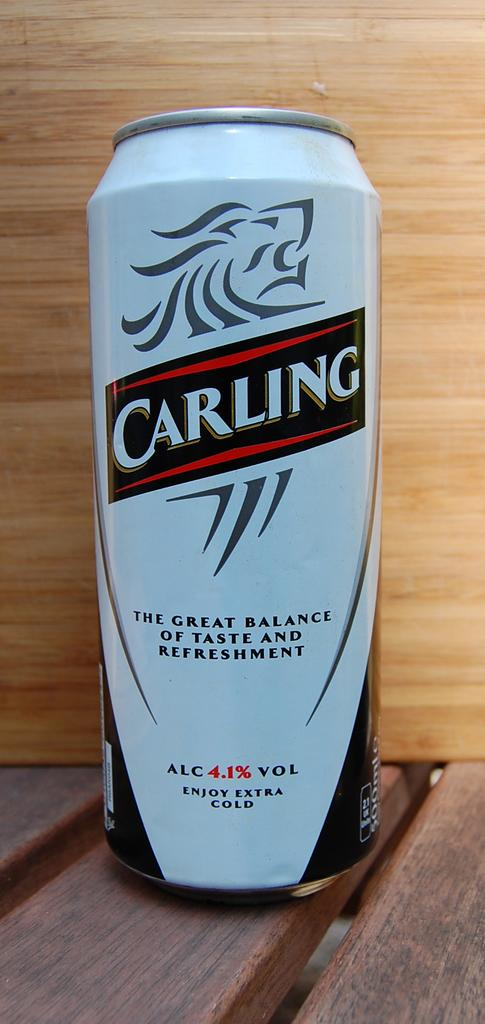Provide a one-sentence caption for the provided image. The Carling motto is, "The great balance of taste and refreshment.". 